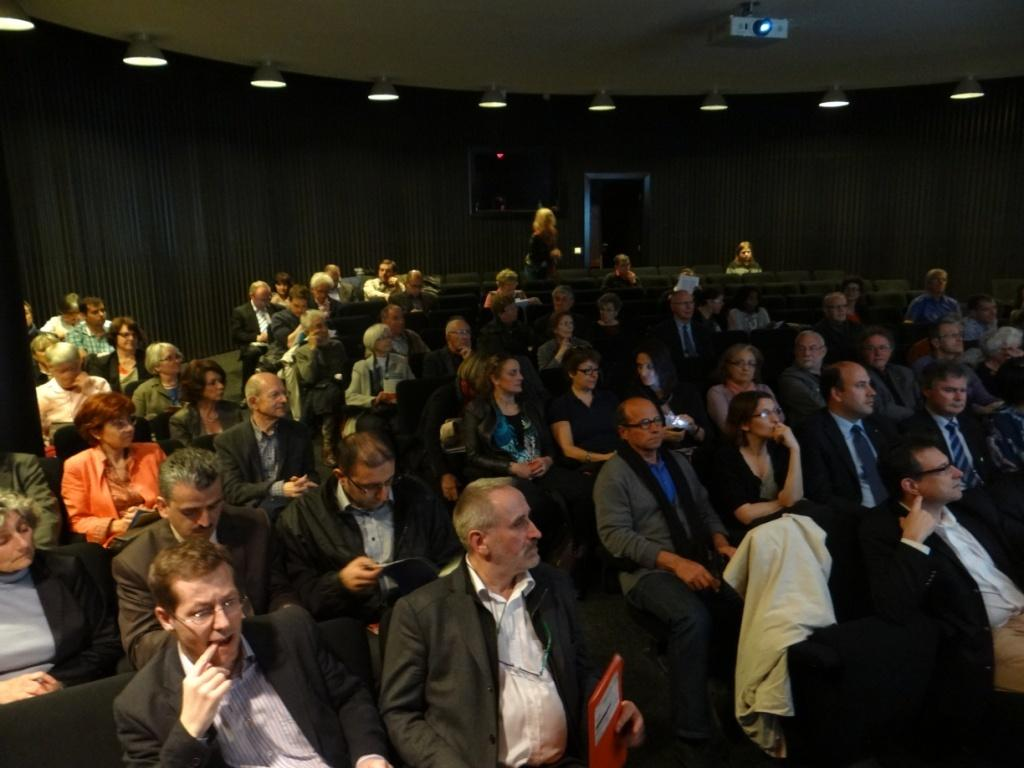What is the main subject of the image? The main subject of the image is a group of people. What are the people in the image doing? The people are sitting on chairs in the image. What device is present in the image that might be used for presentations? There is a projector in the image. What type of lighting is visible in the image? There are lights in the image. What type of structure is present in the background of the image? There is a wall in the image. Can you hear the ocean in the image? There is no reference to the ocean or any sounds in the image, so it's not possible to determine if the ocean can be heard. 